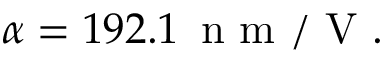<formula> <loc_0><loc_0><loc_500><loc_500>\alpha = 1 9 2 . 1 \, n m / V .</formula> 